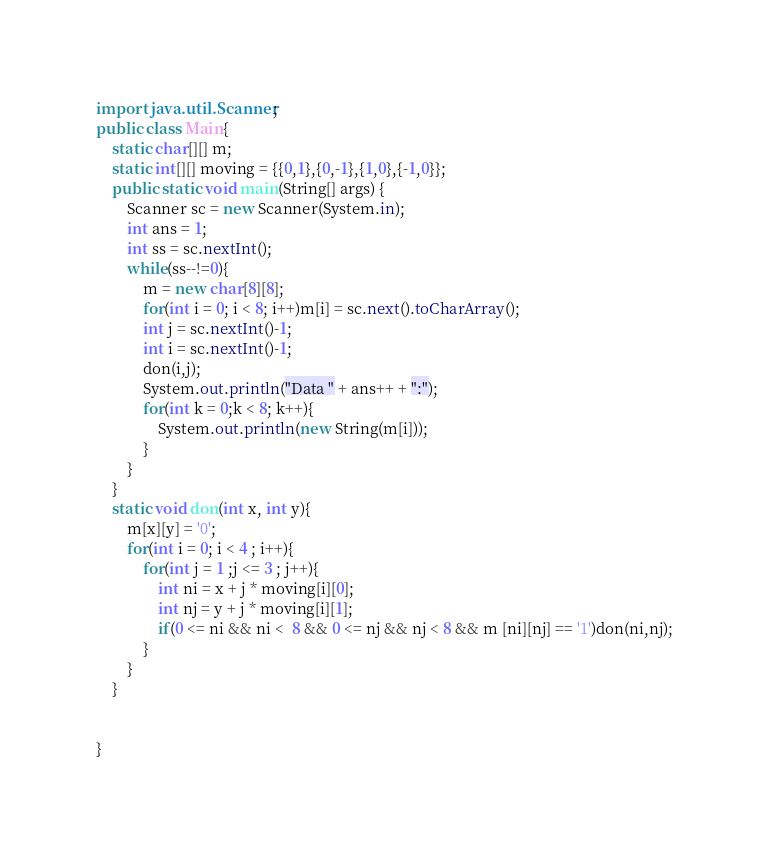<code> <loc_0><loc_0><loc_500><loc_500><_Java_>import java.util.Scanner;
public class Main{
	static char[][] m;
	static int[][] moving = {{0,1},{0,-1},{1,0},{-1,0}};
	public static void main(String[] args) {
		Scanner sc = new Scanner(System.in);
		int ans = 1;
		int ss = sc.nextInt();
		while(ss--!=0){
			m = new char[8][8];
			for(int i = 0; i < 8; i++)m[i] = sc.next().toCharArray();
			int j = sc.nextInt()-1;
			int i = sc.nextInt()-1;
			don(i,j);
			System.out.println("Data " + ans++ + ":");
			for(int k = 0;k < 8; k++){
				System.out.println(new String(m[i]));
			}
		}
	}
	static void don(int x, int y){
		m[x][y] = '0';
		for(int i = 0; i < 4 ; i++){
			for(int j = 1 ;j <= 3 ; j++){
				int ni = x + j * moving[i][0];
				int nj = y + j * moving[i][1];
				if(0 <= ni && ni <  8 && 0 <= nj && nj < 8 && m [ni][nj] == '1')don(ni,nj);
			}
		}
	}

	
}</code> 